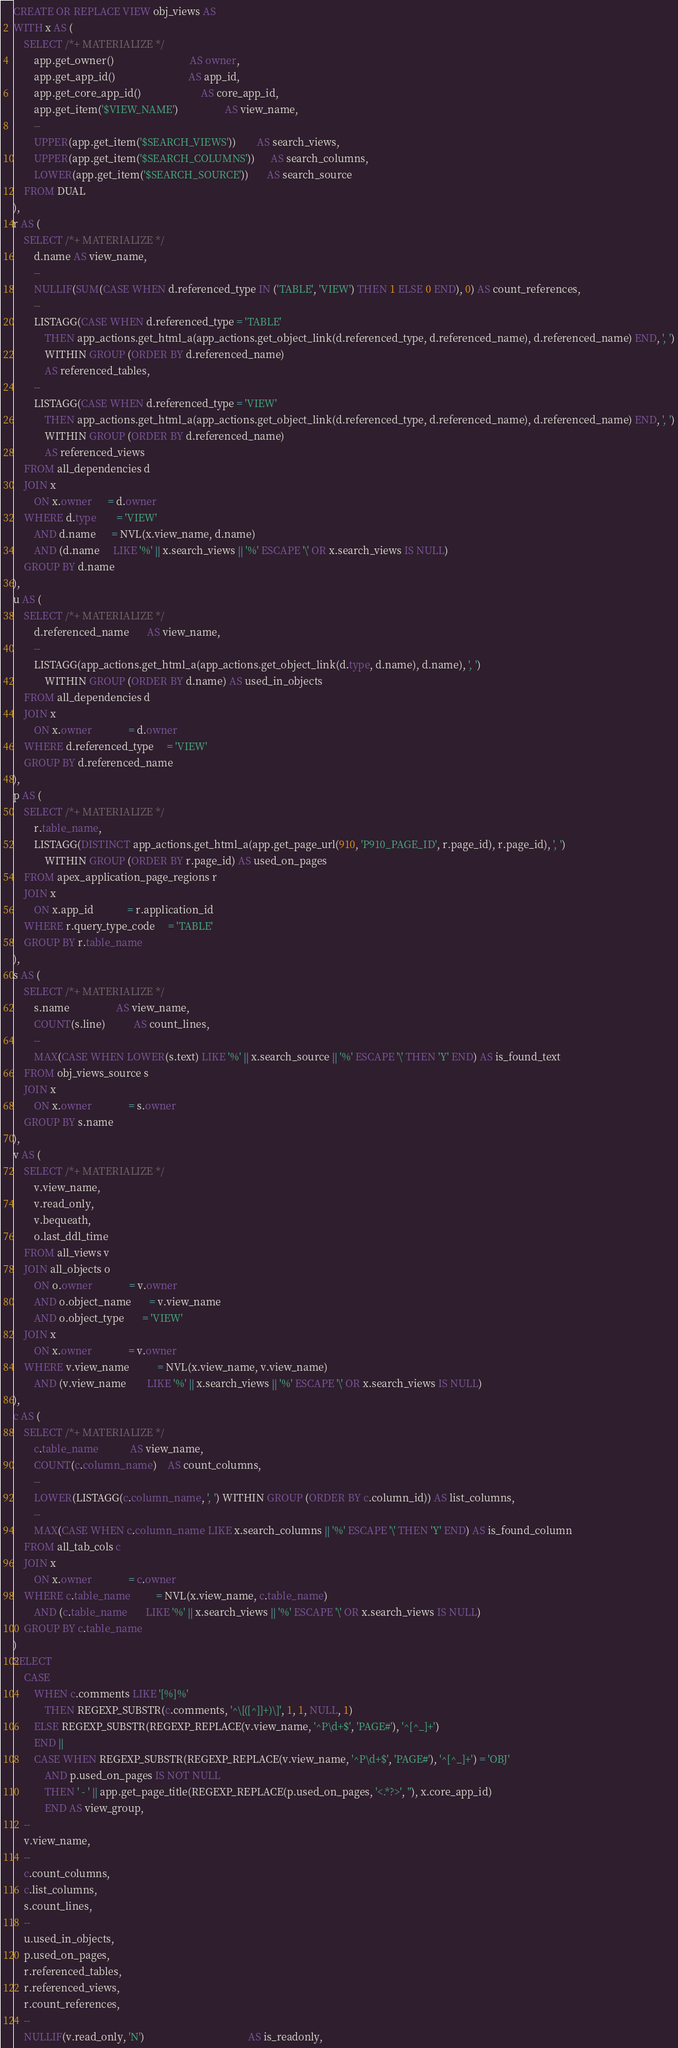Convert code to text. <code><loc_0><loc_0><loc_500><loc_500><_SQL_>CREATE OR REPLACE VIEW obj_views AS
WITH x AS (
    SELECT /*+ MATERIALIZE */
        app.get_owner()                             AS owner,
        app.get_app_id()                            AS app_id,
        app.get_core_app_id()                       AS core_app_id,
        app.get_item('$VIEW_NAME')                  AS view_name,
        --
        UPPER(app.get_item('$SEARCH_VIEWS'))        AS search_views,
        UPPER(app.get_item('$SEARCH_COLUMNS'))      AS search_columns,
        LOWER(app.get_item('$SEARCH_SOURCE'))       AS search_source
    FROM DUAL
),
r AS (
    SELECT /*+ MATERIALIZE */
        d.name AS view_name,
        --
        NULLIF(SUM(CASE WHEN d.referenced_type IN ('TABLE', 'VIEW') THEN 1 ELSE 0 END), 0) AS count_references,
        --
        LISTAGG(CASE WHEN d.referenced_type = 'TABLE'
            THEN app_actions.get_html_a(app_actions.get_object_link(d.referenced_type, d.referenced_name), d.referenced_name) END, ', ')
            WITHIN GROUP (ORDER BY d.referenced_name)
            AS referenced_tables,
        --
        LISTAGG(CASE WHEN d.referenced_type = 'VIEW'
            THEN app_actions.get_html_a(app_actions.get_object_link(d.referenced_type, d.referenced_name), d.referenced_name) END, ', ')
            WITHIN GROUP (ORDER BY d.referenced_name)
            AS referenced_views
    FROM all_dependencies d
    JOIN x
        ON x.owner      = d.owner
    WHERE d.type        = 'VIEW'
        AND d.name      = NVL(x.view_name, d.name)
        AND (d.name     LIKE '%' || x.search_views || '%' ESCAPE '\' OR x.search_views IS NULL)
    GROUP BY d.name
),
u AS (
    SELECT /*+ MATERIALIZE */
        d.referenced_name       AS view_name,
        --
        LISTAGG(app_actions.get_html_a(app_actions.get_object_link(d.type, d.name), d.name), ', ')
            WITHIN GROUP (ORDER BY d.name) AS used_in_objects
    FROM all_dependencies d
    JOIN x
        ON x.owner              = d.owner
    WHERE d.referenced_type     = 'VIEW'
    GROUP BY d.referenced_name
),
p AS (
    SELECT /*+ MATERIALIZE */
        r.table_name,
        LISTAGG(DISTINCT app_actions.get_html_a(app.get_page_url(910, 'P910_PAGE_ID', r.page_id), r.page_id), ', ')
            WITHIN GROUP (ORDER BY r.page_id) AS used_on_pages
    FROM apex_application_page_regions r
    JOIN x
        ON x.app_id             = r.application_id
    WHERE r.query_type_code     = 'TABLE'
    GROUP BY r.table_name
),
s AS (
    SELECT /*+ MATERIALIZE */
        s.name                  AS view_name,
        COUNT(s.line)           AS count_lines,
        --
        MAX(CASE WHEN LOWER(s.text) LIKE '%' || x.search_source || '%' ESCAPE '\' THEN 'Y' END) AS is_found_text
    FROM obj_views_source s
    JOIN x
        ON x.owner              = s.owner
    GROUP BY s.name
),
v AS (
    SELECT /*+ MATERIALIZE */
        v.view_name,
        v.read_only,
        v.bequeath,
        o.last_ddl_time
    FROM all_views v
    JOIN all_objects o
        ON o.owner              = v.owner
        AND o.object_name       = v.view_name
        AND o.object_type       = 'VIEW'
    JOIN x
        ON x.owner              = v.owner
    WHERE v.view_name           = NVL(x.view_name, v.view_name)
        AND (v.view_name        LIKE '%' || x.search_views || '%' ESCAPE '\' OR x.search_views IS NULL)
),
c AS (
    SELECT /*+ MATERIALIZE */
        c.table_name            AS view_name,
        COUNT(c.column_name)    AS count_columns,
        --
        LOWER(LISTAGG(c.column_name, ', ') WITHIN GROUP (ORDER BY c.column_id)) AS list_columns,
        --
        MAX(CASE WHEN c.column_name LIKE x.search_columns || '%' ESCAPE '\' THEN 'Y' END) AS is_found_column
    FROM all_tab_cols c
    JOIN x
        ON x.owner              = c.owner
    WHERE c.table_name          = NVL(x.view_name, c.table_name)
        AND (c.table_name       LIKE '%' || x.search_views || '%' ESCAPE '\' OR x.search_views IS NULL)
    GROUP BY c.table_name
)
SELECT
    CASE
        WHEN c.comments LIKE '[%]%'
            THEN REGEXP_SUBSTR(c.comments, '^\[([^]]+)\]', 1, 1, NULL, 1)
        ELSE REGEXP_SUBSTR(REGEXP_REPLACE(v.view_name, '^P\d+$', 'PAGE#'), '^[^_]+')
        END ||
        CASE WHEN REGEXP_SUBSTR(REGEXP_REPLACE(v.view_name, '^P\d+$', 'PAGE#'), '^[^_]+') = 'OBJ'
            AND p.used_on_pages IS NOT NULL
            THEN ' - ' || app.get_page_title(REGEXP_REPLACE(p.used_on_pages, '<.*?>', ''), x.core_app_id)
            END AS view_group,
    --
    v.view_name,
    --
    c.count_columns,
    c.list_columns,
    s.count_lines,
    --
    u.used_in_objects,
    p.used_on_pages,
    r.referenced_tables,
    r.referenced_views,
    r.count_references,
    --
    NULLIF(v.read_only, 'N')                                        AS is_readonly,</code> 